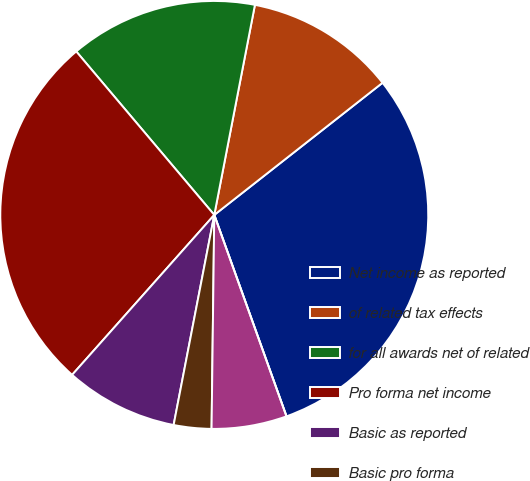Convert chart. <chart><loc_0><loc_0><loc_500><loc_500><pie_chart><fcel>Net income as reported<fcel>of related tax effects<fcel>for all awards net of related<fcel>Pro forma net income<fcel>Basic as reported<fcel>Basic pro forma<fcel>Diluted as reported<fcel>Diluted pro forma<nl><fcel>30.11%<fcel>11.36%<fcel>14.2%<fcel>27.27%<fcel>8.52%<fcel>2.84%<fcel>5.68%<fcel>0.0%<nl></chart> 